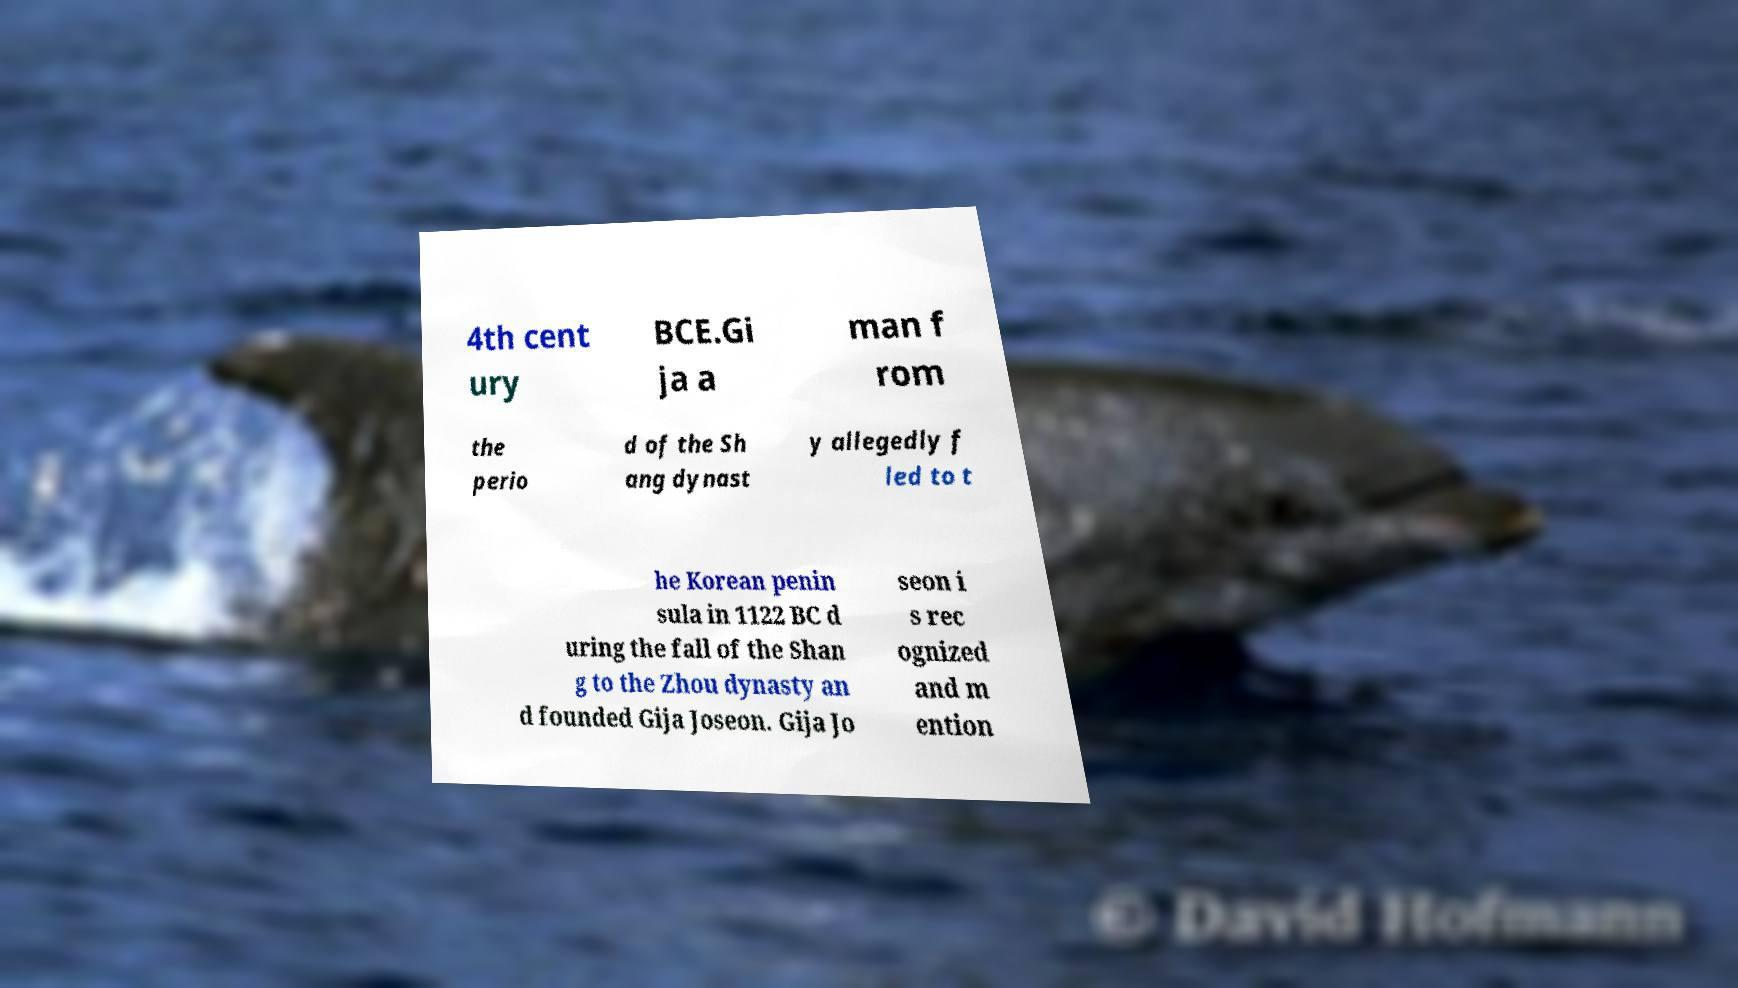What messages or text are displayed in this image? I need them in a readable, typed format. 4th cent ury BCE.Gi ja a man f rom the perio d of the Sh ang dynast y allegedly f led to t he Korean penin sula in 1122 BC d uring the fall of the Shan g to the Zhou dynasty an d founded Gija Joseon. Gija Jo seon i s rec ognized and m ention 